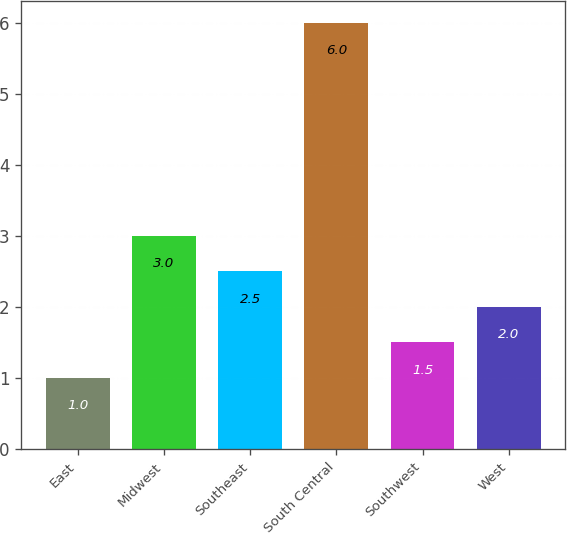Convert chart to OTSL. <chart><loc_0><loc_0><loc_500><loc_500><bar_chart><fcel>East<fcel>Midwest<fcel>Southeast<fcel>South Central<fcel>Southwest<fcel>West<nl><fcel>1<fcel>3<fcel>2.5<fcel>6<fcel>1.5<fcel>2<nl></chart> 